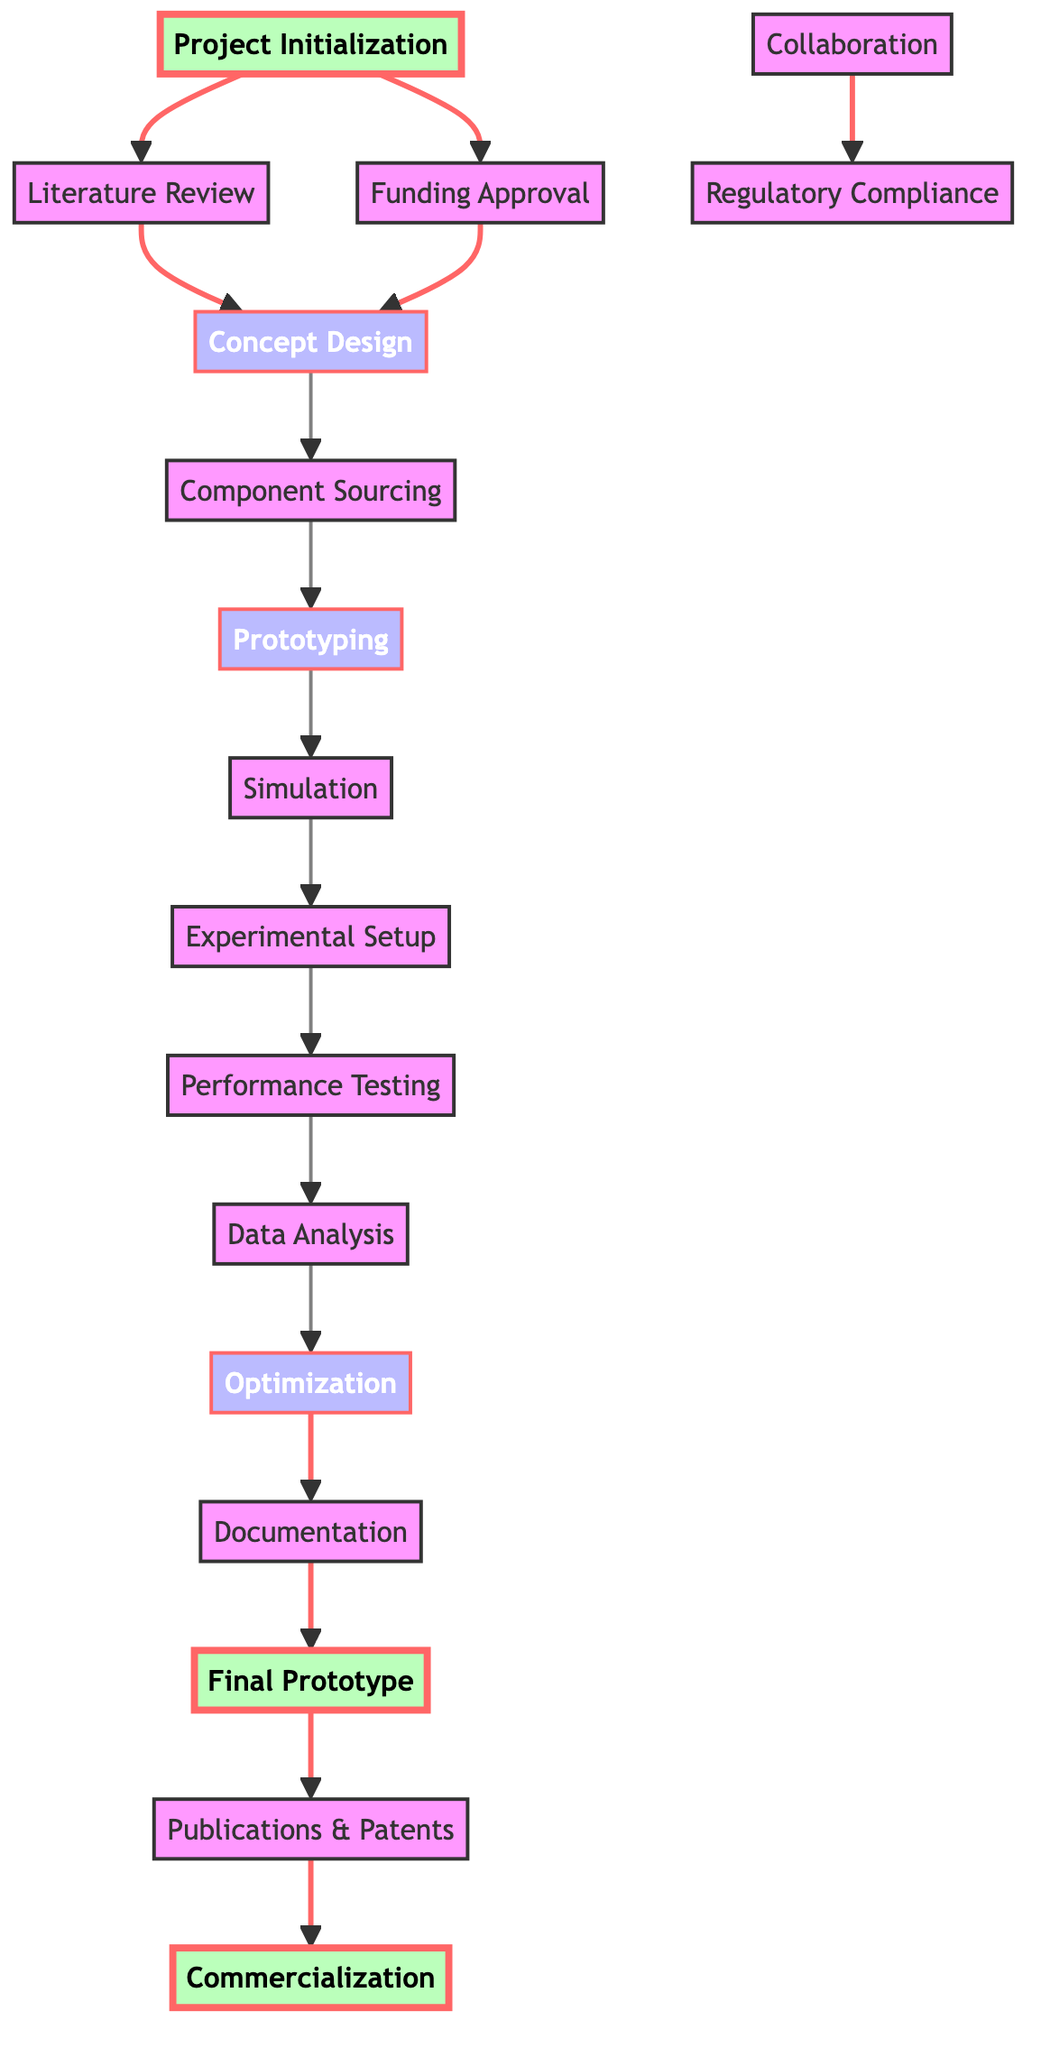What is the title of the first node? The title of the first node can be found at the top of the diagram, which clearly identifies the project initiation phase as "Project Initialization and Planning."
Answer: Project Initialization and Planning Which nodes are directly connected to the "Funding and Budget Approval"? To find the nodes connected to "Funding and Budget Approval," look for edges leading to and from this node; it connects to "Concept Design."
Answer: Concept Design How many total nodes are present in the diagram? Count each listed node in the diagram; there are 17 nodes, each representing a step in the workflow.
Answer: 17 What is the last node in the process? The last node can be identified by following the directed edges from the previous nodes; it culminates in "Commercialization."
Answer: Commercialization What two nodes are prerequisites for the "Performance Testing"? To identify prerequisites for "Performance Testing," look at which nodes lead into it; the prerequisites are "Experimental Setup" and "Prototyping."
Answer: Experimental Setup and Prototyping Identify the node that follows "Data Analysis." Check the edge connections to see which node comes after "Data Analysis"; it leads to "Optimization."
Answer: Optimization Which node is associated with safety and regulatory requirements? Check the connections to see which node directly pertains to safety guidelines; "Regulatory Compliance" addresses this aspect.
Answer: Regulatory Compliance How many nodes represent milestones in the workflow? Review the diagram for nodes marked as milestones; the milestones in this context are "Project Initialization," "Final Prototype," and "Commercialization," totaling three.
Answer: 3 What is the relationship between "Collaboration" and "Regulatory Compliance"? Examine the flows in the diagram; "Collaboration" and "Regulatory Compliance" are connected through collaboration activities but do not connect directly in the flow.
Answer: No direct connection 